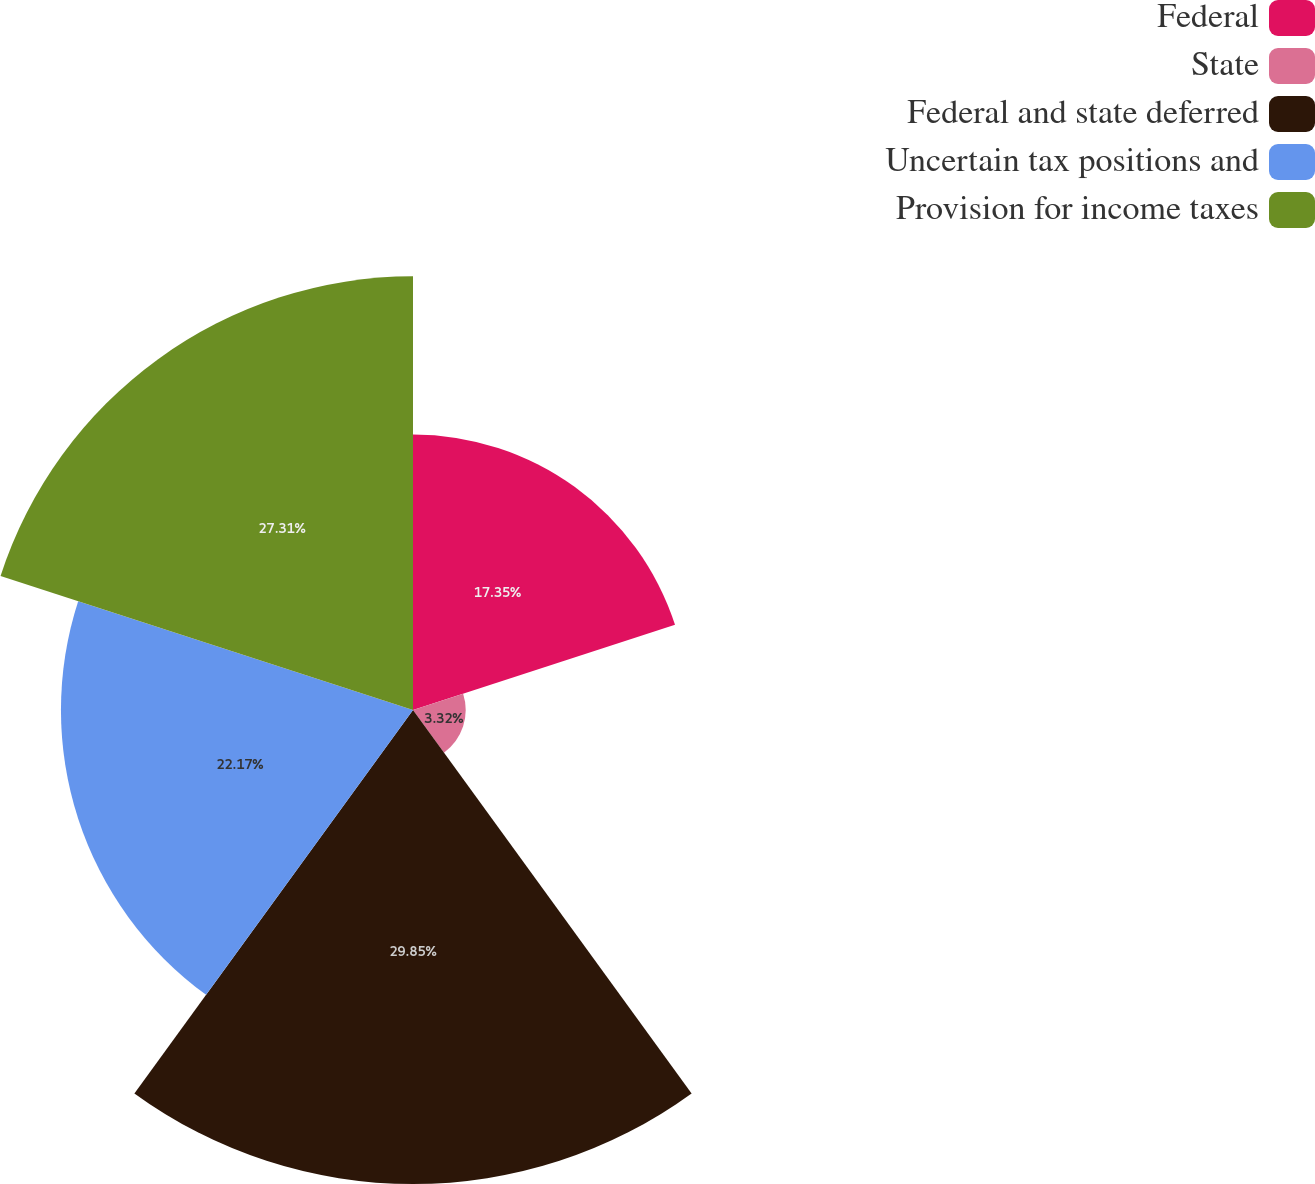<chart> <loc_0><loc_0><loc_500><loc_500><pie_chart><fcel>Federal<fcel>State<fcel>Federal and state deferred<fcel>Uncertain tax positions and<fcel>Provision for income taxes<nl><fcel>17.35%<fcel>3.32%<fcel>29.85%<fcel>22.17%<fcel>27.31%<nl></chart> 